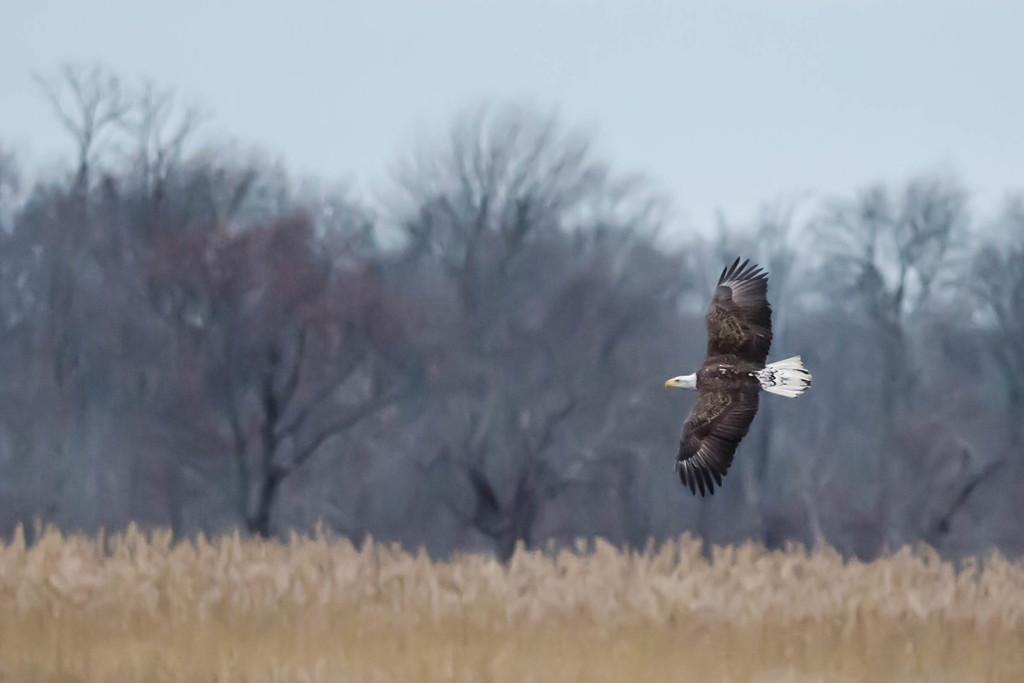What is the main subject of the image? There is a bird flying in the air in the image. What can be seen in the background of the image? There are plants, trees, and the sky visible in the background of the image. How is the background of the image depicted? The background of the image is blurred. What type of horse can be seen drawing a carriage in the image? There is no horse or carriage present in the image; it features a bird flying in the air. What material is the chalk made of in the image? There is no chalk present in the image. 